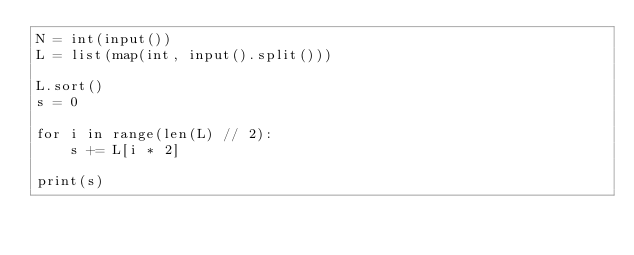Convert code to text. <code><loc_0><loc_0><loc_500><loc_500><_Python_>N = int(input())
L = list(map(int, input().split()))

L.sort()
s = 0

for i in range(len(L) // 2):
    s += L[i * 2]

print(s)</code> 